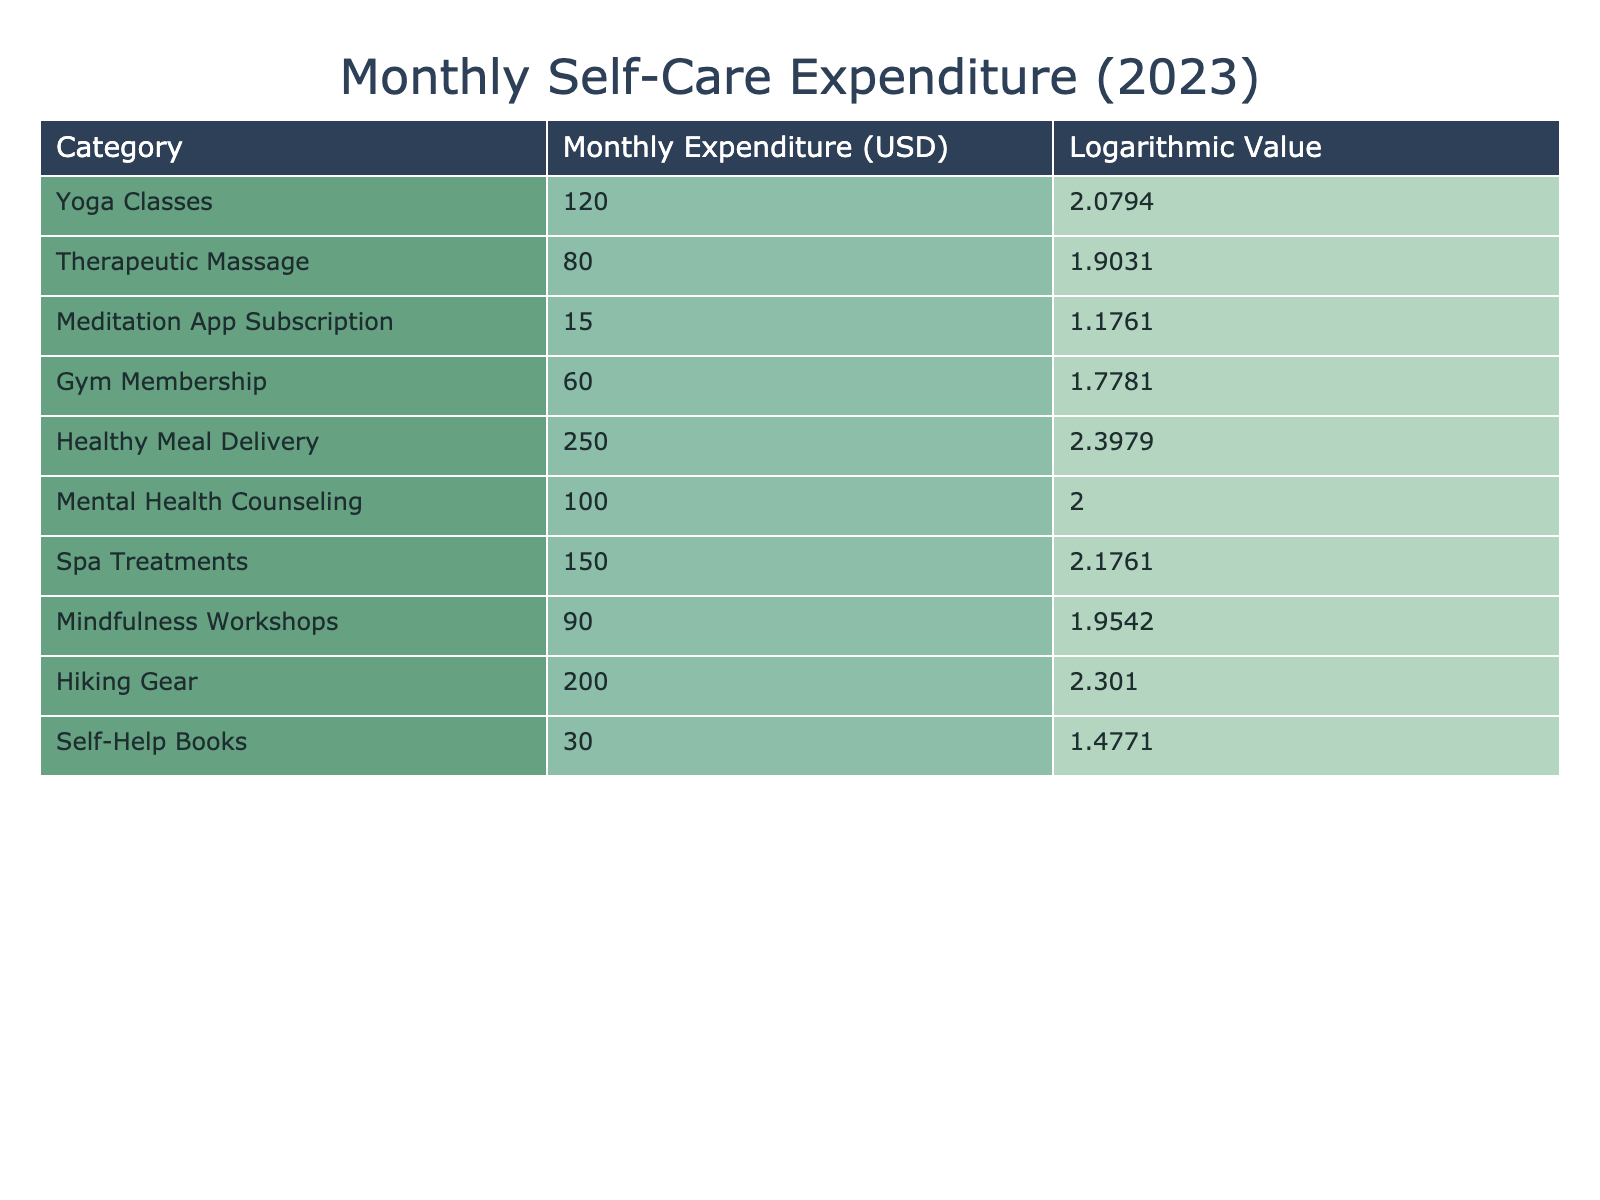What is the monthly expenditure on Yoga Classes? The table clearly indicates that the monthly expenditure for Yoga Classes is listed under the "Monthly Expenditure (USD)" column. The value next to Yoga Classes is 120.
Answer: 120 What is the logarithmic value of Spa Treatments? The logarithmic value is provided in the table next to the Spa Treatments row. It clearly states that the value is 2.1761.
Answer: 2.1761 Which category has the highest monthly expenditure, and what is that amount? By reviewing the "Monthly Expenditure (USD)" column, Healthy Meal Delivery has the highest amount listed at 250.
Answer: 250 What is the total monthly expenditure on self-care and wellness activities provided? To find the total, we can sum up all the values in the "Monthly Expenditure (USD)" column: 120 + 80 + 15 + 60 + 250 + 100 + 150 + 90 + 200 + 30 = 1,095.
Answer: 1095 Is the expenditure on Meditation App Subscription higher than that on Self-Help Books? We compare the two amounts in the table: Meditation App Subscription is 15, and Self-Help Books is 30. Since 15 is less than 30, the statement is false.
Answer: No What is the average monthly expenditure across all the wellness activities listed? To compute the average, first sum all expenditures (1,095), then divide by the total number of categories (10): 1,095 / 10 = 109.5.
Answer: 109.5 Is it true that the expenditure on Gym Membership is equivalent to the expenditure on Mental Health Counseling? The table lists Gym Membership at 60 and Mental Health Counseling at 100. Since these two numbers are not equal, the answer is false.
Answer: No What is the difference between the highest and lowest expenditures in the table? Identify the highest (Healthy Meal Delivery, 250) and lowest (Meditation App Subscription, 15) values. The difference is calculated as 250 - 15 = 235.
Answer: 235 Which wellness activity has a logarithmic value below 2? By reviewing the "Logarithmic Value" column, we find that the only category with a logarithmic value below 2 is the Meditation App Subscription, which has a value of 1.1761.
Answer: Meditation App Subscription 